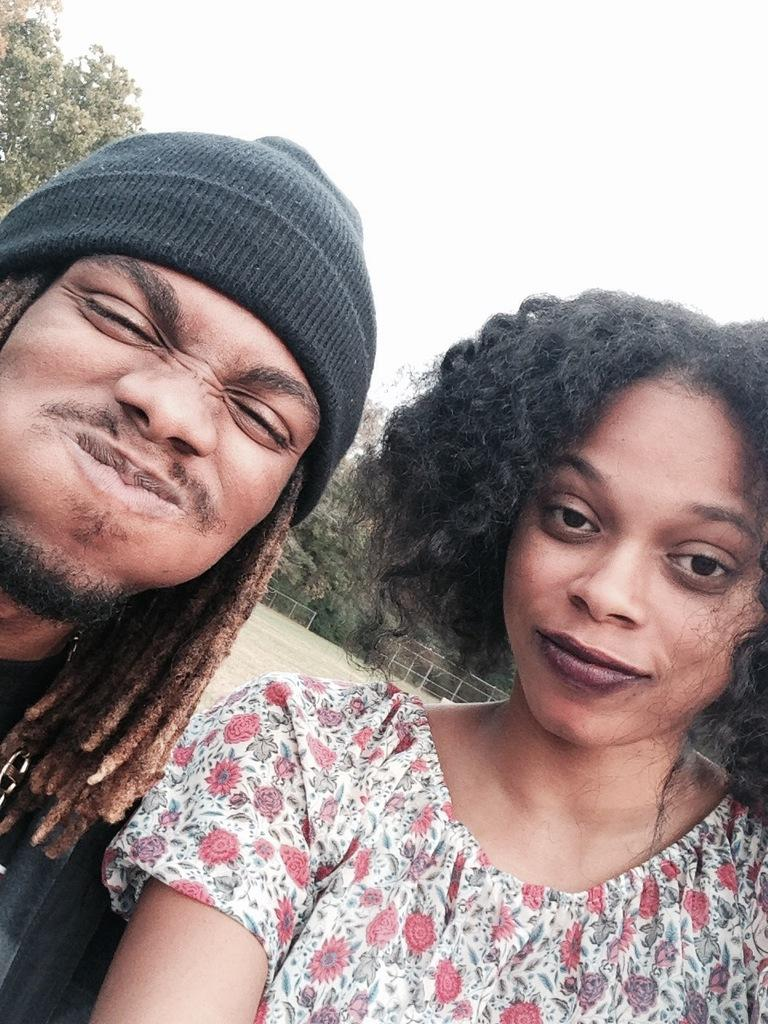How many people are present in the image? There are two people, a man and a woman, present in the image. What are the man and woman doing in the image? Both the man and woman are posing for a camera in the image. What can be seen in the background of the image? There are trees and the sky visible in the background of the image. What type of robin can be seen perched on the man's shoulder in the image? There is no robin present in the image; it only features a man and a woman posing for a camera. Can you tell me how many fangs the woman has in the image? There are no fangs visible in the image, as it only features a man and a woman posing for a camera. 